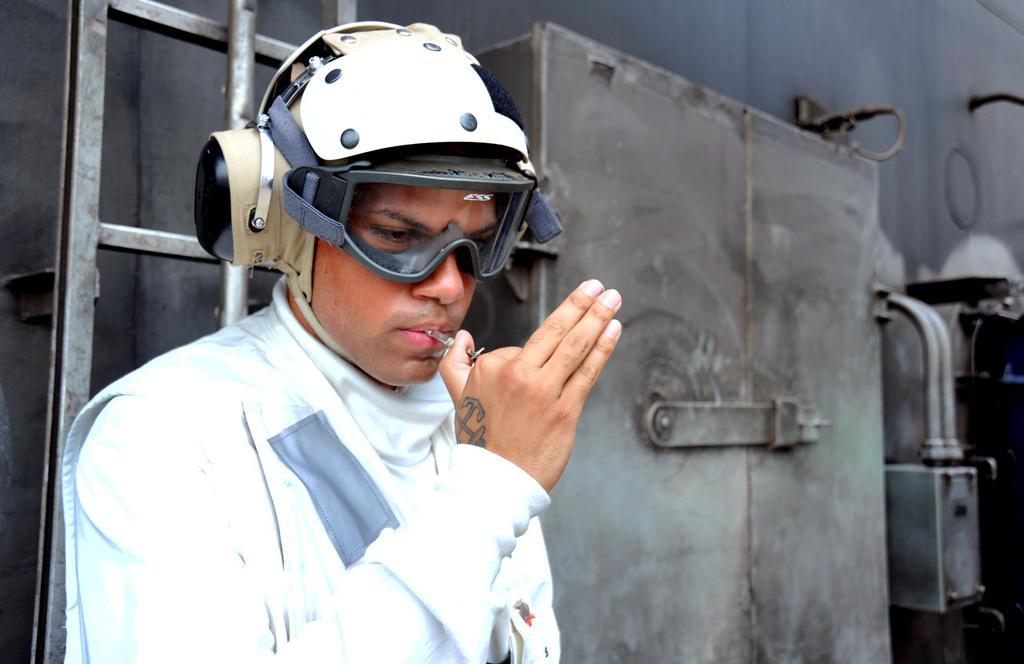Could you give a brief overview of what you see in this image? In this picture I can see a man in front and I see that he is wearing a helmet and a scientific goggles. I can also see that he is holding a thing. In the background I can see few equipment and the rods. 